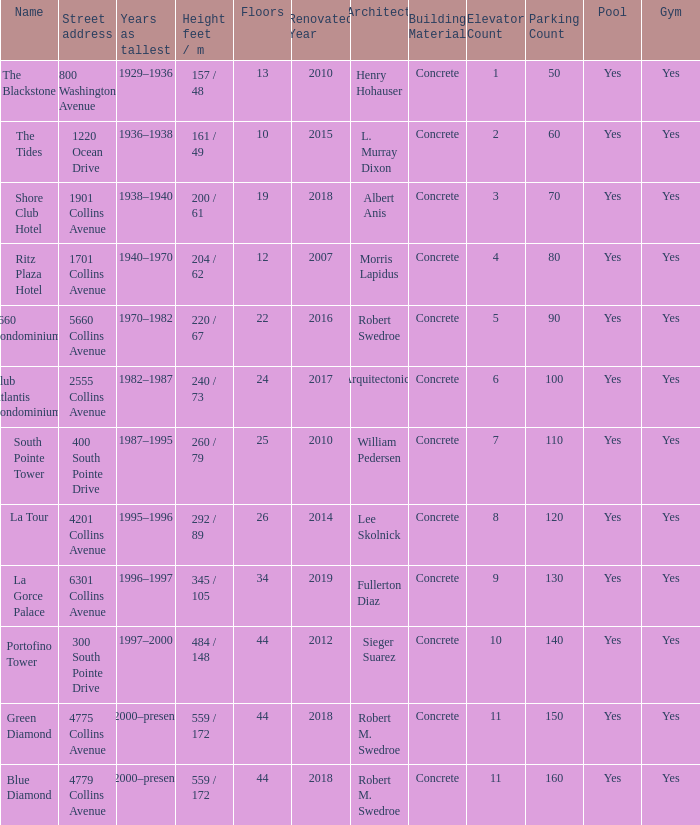How many floors does the Blue Diamond have? 44.0. 